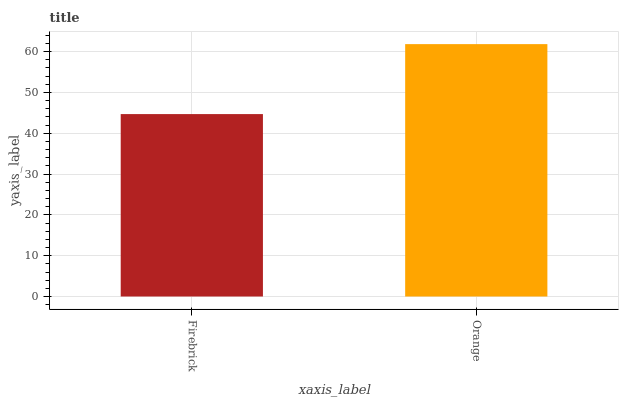Is Firebrick the minimum?
Answer yes or no. Yes. Is Orange the maximum?
Answer yes or no. Yes. Is Orange the minimum?
Answer yes or no. No. Is Orange greater than Firebrick?
Answer yes or no. Yes. Is Firebrick less than Orange?
Answer yes or no. Yes. Is Firebrick greater than Orange?
Answer yes or no. No. Is Orange less than Firebrick?
Answer yes or no. No. Is Orange the high median?
Answer yes or no. Yes. Is Firebrick the low median?
Answer yes or no. Yes. Is Firebrick the high median?
Answer yes or no. No. Is Orange the low median?
Answer yes or no. No. 